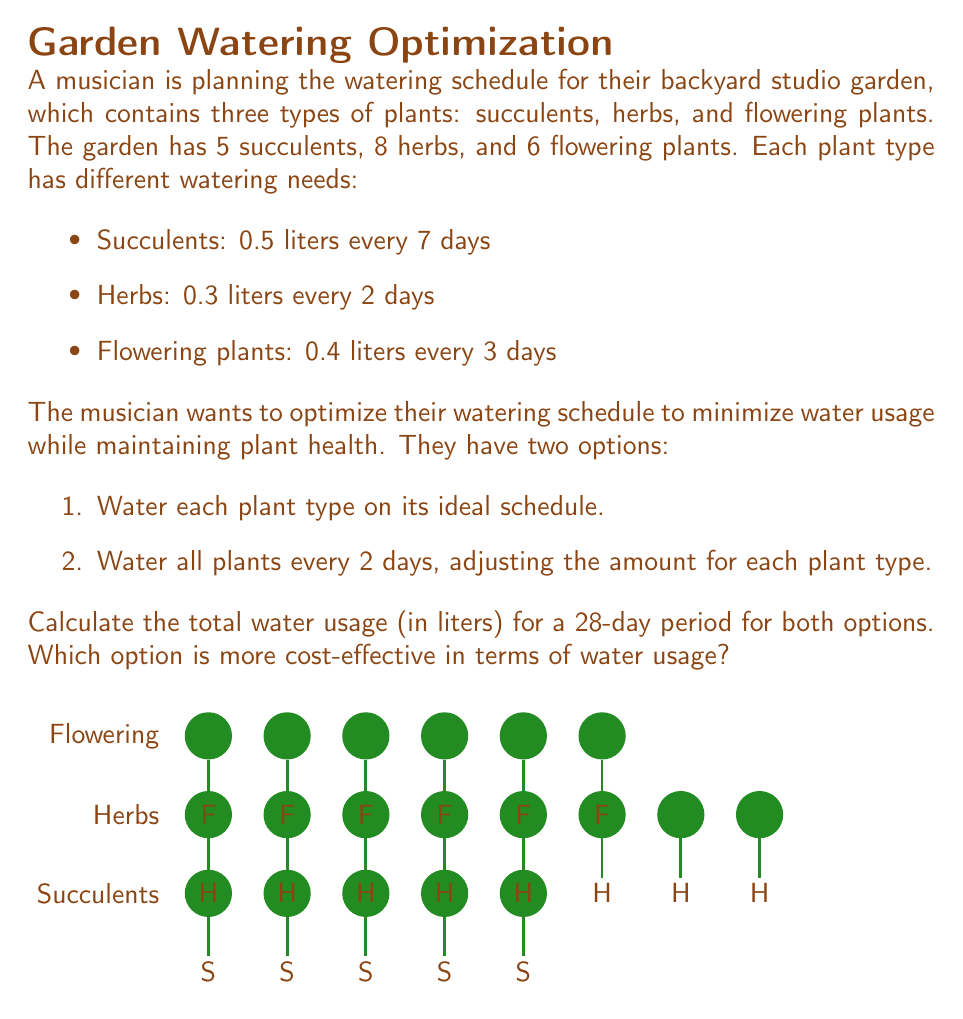What is the answer to this math problem? Let's solve this problem step by step:

1. Calculate water usage for Option 1 (ideal schedule):

   Succulents: 
   $$5 \text{ plants} \times 0.5 \text{ L} \times \frac{28 \text{ days}}{7 \text{ days}} = 10 \text{ L}$$

   Herbs: 
   $$8 \text{ plants} \times 0.3 \text{ L} \times \frac{28 \text{ days}}{2 \text{ days}} = 33.6 \text{ L}$$

   Flowering plants: 
   $$6 \text{ plants} \times 0.4 \text{ L} \times \frac{28 \text{ days}}{3 \text{ days}} = 22.4 \text{ L}$$

   Total for Option 1: $10 + 33.6 + 22.4 = 66 \text{ L}$

2. Calculate water usage for Option 2 (watering every 2 days):

   Succulents: 
   $$5 \text{ plants} \times (0.5 \text{ L} \times \frac{2 \text{ days}}{7 \text{ days}}) \times \frac{28 \text{ days}}{2 \text{ days}} = 10 \text{ L}$$

   Herbs: 
   $$8 \text{ plants} \times 0.3 \text{ L} \times \frac{28 \text{ days}}{2 \text{ days}} = 33.6 \text{ L}$$

   Flowering plants: 
   $$6 \text{ plants} \times (0.4 \text{ L} \times \frac{2 \text{ days}}{3 \text{ days}}) \times \frac{28 \text{ days}}{2 \text{ days}} = 22.4 \text{ L}$$

   Total for Option 2: $10 + 33.6 + 22.4 = 66 \text{ L}$

3. Compare the two options:
   Both options result in the same total water usage of 66 liters over 28 days.
Answer: Both options use 66 L; equally cost-effective. 